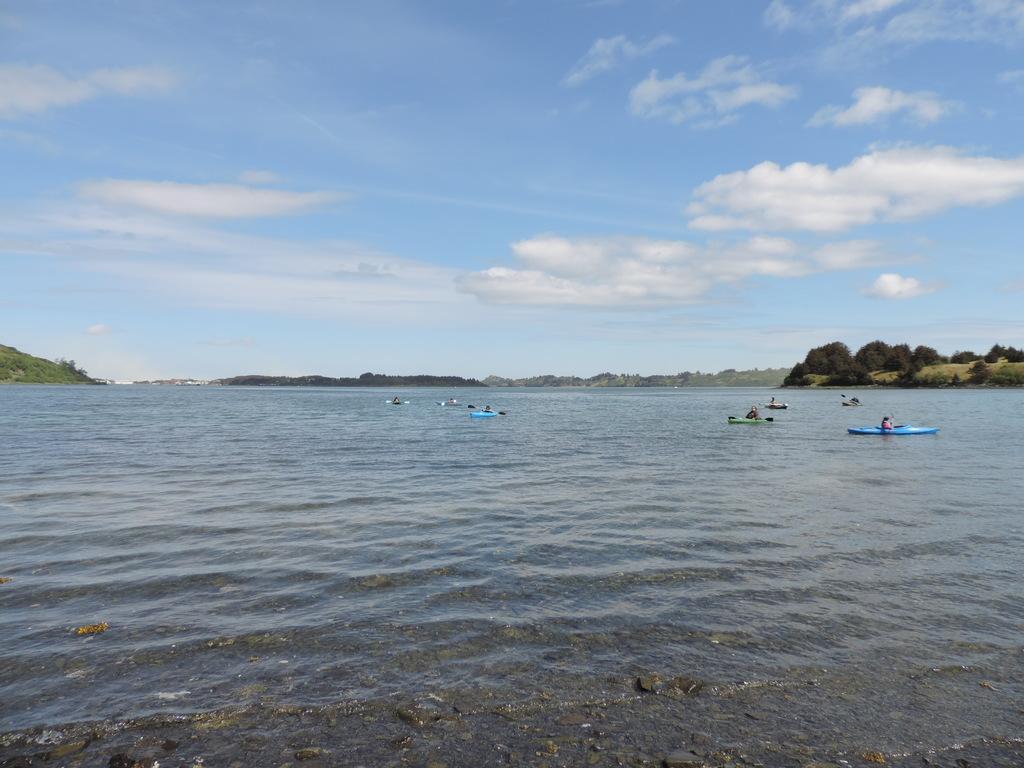Please provide a concise description of this image. In the center of the image we can see the sky, clouds, trees, water boats and a few other objects. 